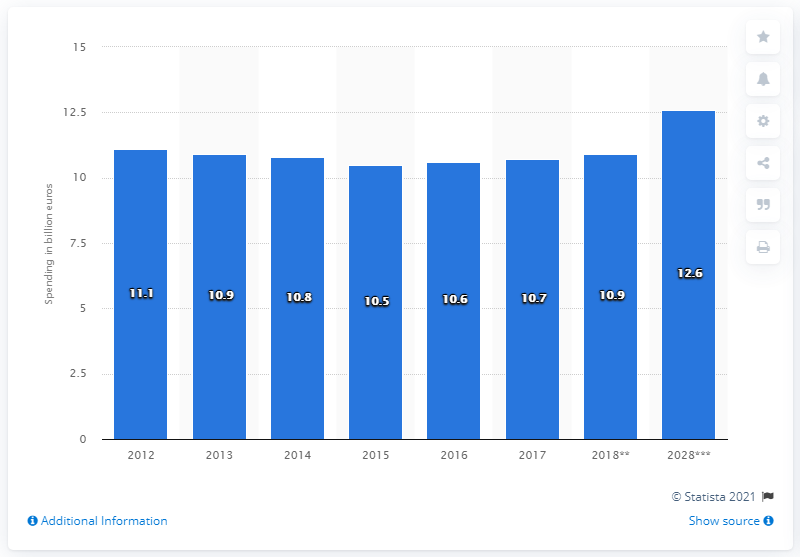List a handful of essential elements in this visual. The mode is 10.9.. In 2018, it is estimated that Finland's domestic travel and tourism spending will reach a total of 10.9 billion euros. The year 2028 is the only future year depicted in the graph. 